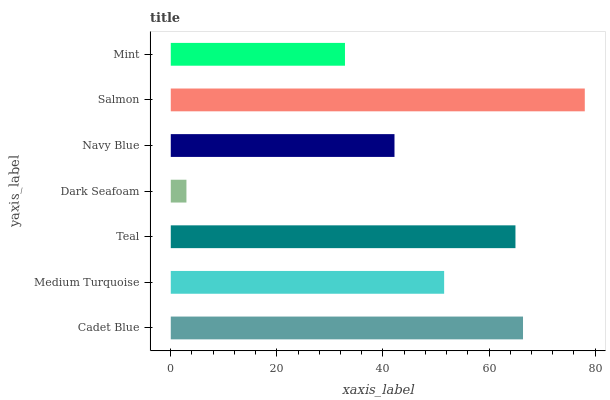Is Dark Seafoam the minimum?
Answer yes or no. Yes. Is Salmon the maximum?
Answer yes or no. Yes. Is Medium Turquoise the minimum?
Answer yes or no. No. Is Medium Turquoise the maximum?
Answer yes or no. No. Is Cadet Blue greater than Medium Turquoise?
Answer yes or no. Yes. Is Medium Turquoise less than Cadet Blue?
Answer yes or no. Yes. Is Medium Turquoise greater than Cadet Blue?
Answer yes or no. No. Is Cadet Blue less than Medium Turquoise?
Answer yes or no. No. Is Medium Turquoise the high median?
Answer yes or no. Yes. Is Medium Turquoise the low median?
Answer yes or no. Yes. Is Navy Blue the high median?
Answer yes or no. No. Is Cadet Blue the low median?
Answer yes or no. No. 